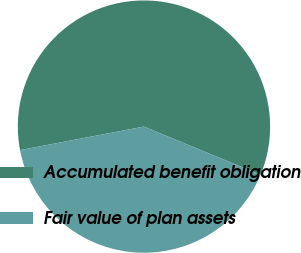<chart> <loc_0><loc_0><loc_500><loc_500><pie_chart><fcel>Accumulated benefit obligation<fcel>Fair value of plan assets<nl><fcel>59.22%<fcel>40.78%<nl></chart> 